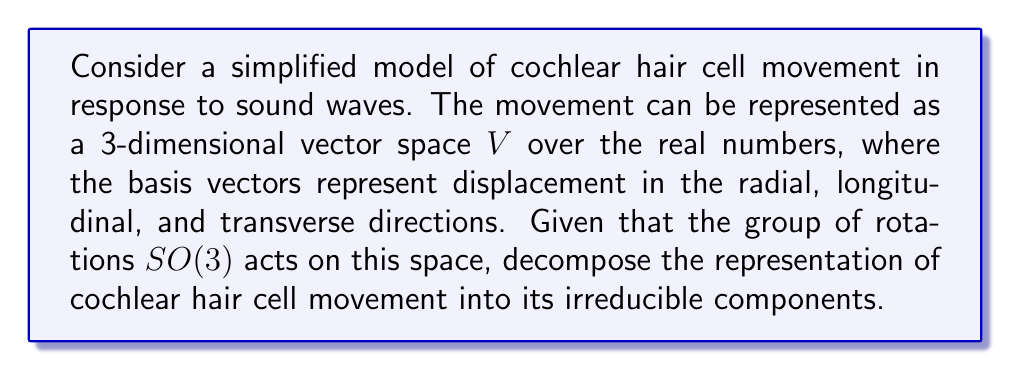Can you solve this math problem? Let's approach this step-by-step:

1) First, we recognize that the 3-dimensional vector space $V$ is the standard representation of $SO(3)$.

2) For $SO(3)$, we know that the irreducible representations are characterized by their dimension $2l+1$, where $l$ is a non-negative integer.

3) The standard representation of $SO(3)$ is 3-dimensional, corresponding to $l=1$.

4) For $l=1$, the representation is already irreducible. This means that there are no invariant subspaces under the action of $SO(3)$ other than $\{0\}$ and $V$ itself.

5) Therefore, the decomposition of $V$ into irreducible components is simply:

   $$V \cong V_1$$

   where $V_1$ denotes the irreducible 3-dimensional representation of $SO(3)$.

6) In the context of cochlear hair cell movement, this means that the three directions of movement (radial, longitudinal, and transverse) are fundamentally interconnected under rotations and cannot be further decomposed into simpler, rotation-invariant components.
Answer: $V \cong V_1$ 